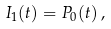Convert formula to latex. <formula><loc_0><loc_0><loc_500><loc_500>I _ { 1 } ( t ) = P _ { 0 } ( t ) \, ,</formula> 